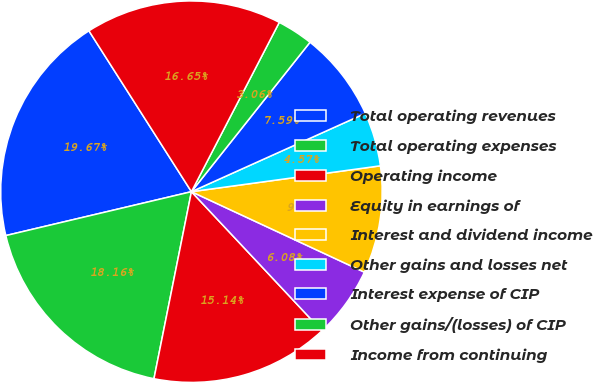<chart> <loc_0><loc_0><loc_500><loc_500><pie_chart><fcel>Total operating revenues<fcel>Total operating expenses<fcel>Operating income<fcel>Equity in earnings of<fcel>Interest and dividend income<fcel>Other gains and losses net<fcel>Interest expense of CIP<fcel>Other gains/(losses) of CIP<fcel>Income from continuing<nl><fcel>19.67%<fcel>18.16%<fcel>15.14%<fcel>6.08%<fcel>9.1%<fcel>4.57%<fcel>7.59%<fcel>3.06%<fcel>16.65%<nl></chart> 